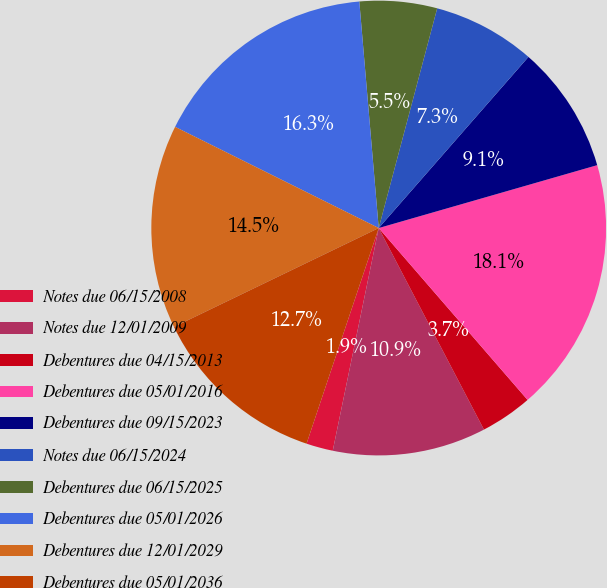Convert chart to OTSL. <chart><loc_0><loc_0><loc_500><loc_500><pie_chart><fcel>Notes due 06/15/2008<fcel>Notes due 12/01/2009<fcel>Debentures due 04/15/2013<fcel>Debentures due 05/01/2016<fcel>Debentures due 09/15/2023<fcel>Notes due 06/15/2024<fcel>Debentures due 06/15/2025<fcel>Debentures due 05/01/2026<fcel>Debentures due 12/01/2029<fcel>Debentures due 05/01/2036<nl><fcel>1.9%<fcel>10.9%<fcel>3.7%<fcel>18.1%<fcel>9.1%<fcel>7.3%<fcel>5.5%<fcel>16.3%<fcel>14.5%<fcel>12.7%<nl></chart> 